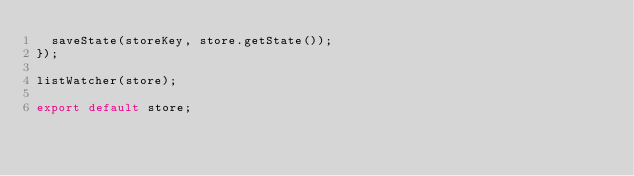Convert code to text. <code><loc_0><loc_0><loc_500><loc_500><_JavaScript_>  saveState(storeKey, store.getState());
});

listWatcher(store);

export default store;
</code> 